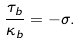Convert formula to latex. <formula><loc_0><loc_0><loc_500><loc_500>\frac { \tau _ { b } } { \kappa _ { b } } = - \sigma .</formula> 